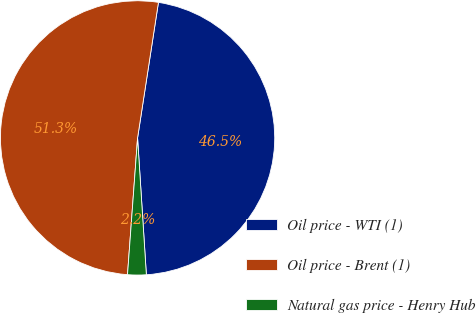Convert chart. <chart><loc_0><loc_0><loc_500><loc_500><pie_chart><fcel>Oil price - WTI (1)<fcel>Oil price - Brent (1)<fcel>Natural gas price - Henry Hub<nl><fcel>46.55%<fcel>51.27%<fcel>2.19%<nl></chart> 